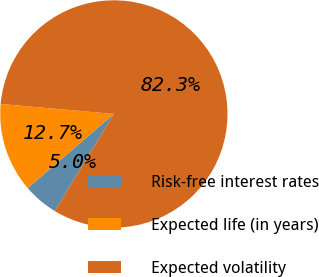Convert chart. <chart><loc_0><loc_0><loc_500><loc_500><pie_chart><fcel>Risk-free interest rates<fcel>Expected life (in years)<fcel>Expected volatility<nl><fcel>4.99%<fcel>12.72%<fcel>82.29%<nl></chart> 